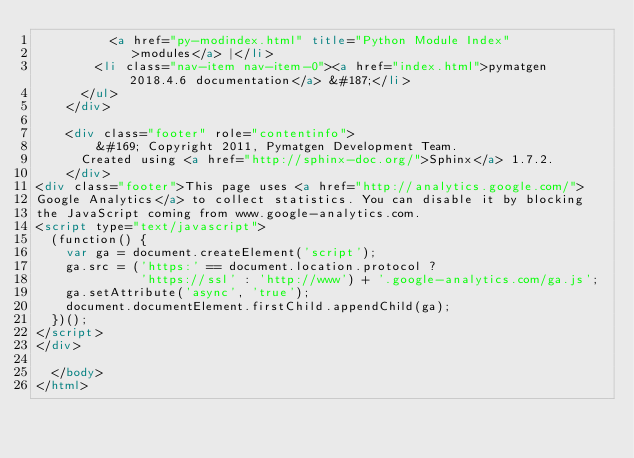Convert code to text. <code><loc_0><loc_0><loc_500><loc_500><_HTML_>          <a href="py-modindex.html" title="Python Module Index"
             >modules</a> |</li>
        <li class="nav-item nav-item-0"><a href="index.html">pymatgen 2018.4.6 documentation</a> &#187;</li> 
      </ul>
    </div>

    <div class="footer" role="contentinfo">
        &#169; Copyright 2011, Pymatgen Development Team.
      Created using <a href="http://sphinx-doc.org/">Sphinx</a> 1.7.2.
    </div>
<div class="footer">This page uses <a href="http://analytics.google.com/">
Google Analytics</a> to collect statistics. You can disable it by blocking
the JavaScript coming from www.google-analytics.com.
<script type="text/javascript">
  (function() {
    var ga = document.createElement('script');
    ga.src = ('https:' == document.location.protocol ?
              'https://ssl' : 'http://www') + '.google-analytics.com/ga.js';
    ga.setAttribute('async', 'true');
    document.documentElement.firstChild.appendChild(ga);
  })();
</script>
</div>

  </body>
</html></code> 